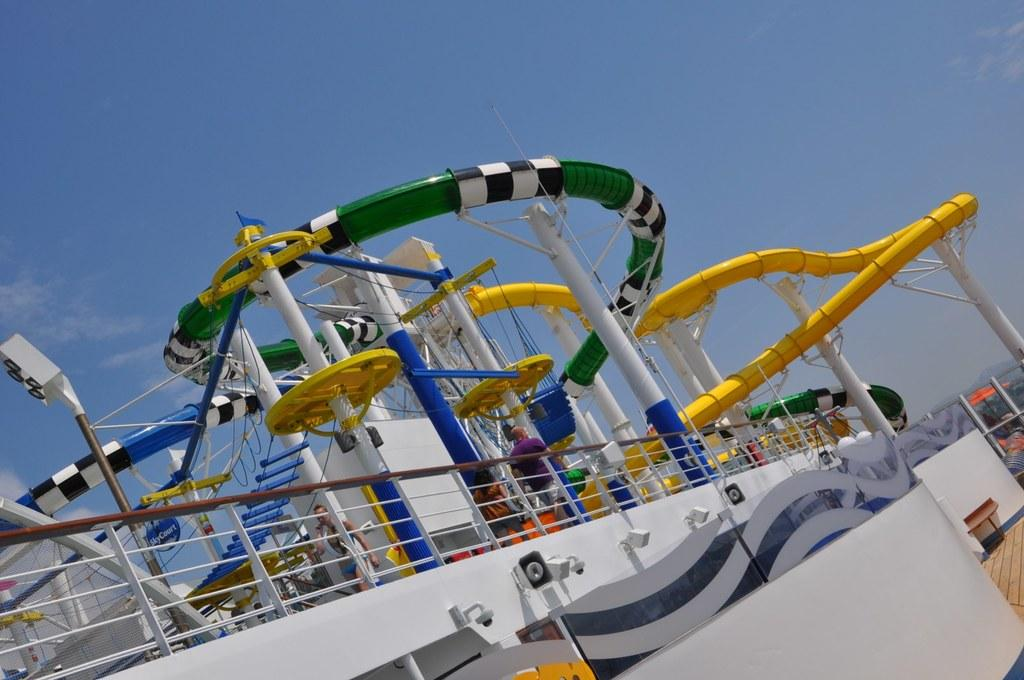What can be seen in the foreground of the image? There are amusement rides in the foreground of the image. What is visible in the background of the image? The sky is visible in the image. What can be observed in the sky? Clouds are present in the sky. What type of calculator can be seen on the amusement ride in the image? There is no calculator present on the amusement ride in the image. 